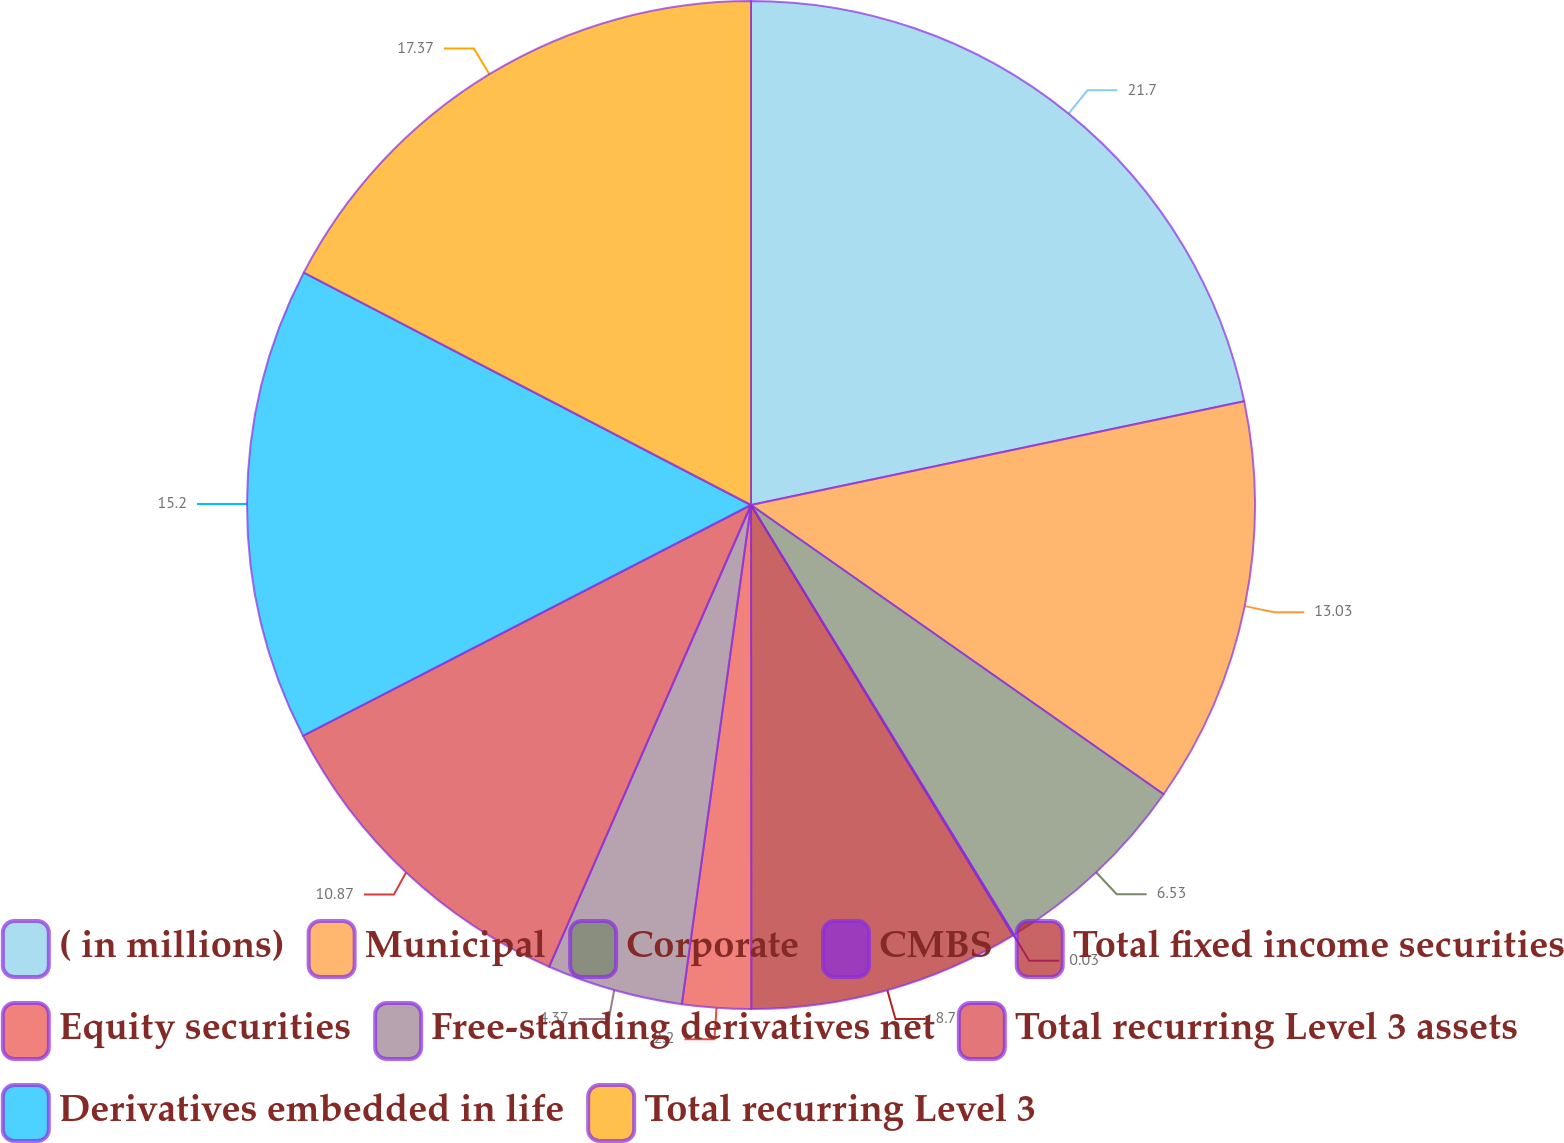<chart> <loc_0><loc_0><loc_500><loc_500><pie_chart><fcel>( in millions)<fcel>Municipal<fcel>Corporate<fcel>CMBS<fcel>Total fixed income securities<fcel>Equity securities<fcel>Free-standing derivatives net<fcel>Total recurring Level 3 assets<fcel>Derivatives embedded in life<fcel>Total recurring Level 3<nl><fcel>21.7%<fcel>13.03%<fcel>6.53%<fcel>0.03%<fcel>8.7%<fcel>2.2%<fcel>4.37%<fcel>10.87%<fcel>15.2%<fcel>17.37%<nl></chart> 